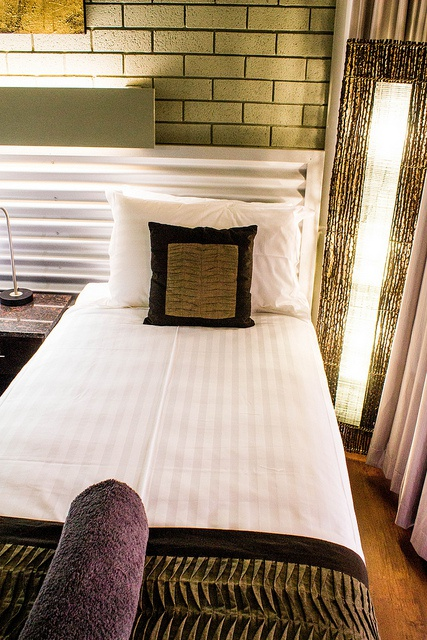Describe the objects in this image and their specific colors. I can see a bed in orange, lightgray, black, and tan tones in this image. 